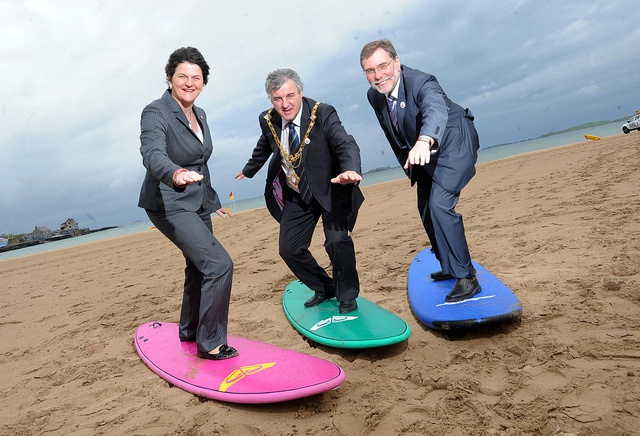Describe the objects in this image and their specific colors. I can see people in white, black, gray, and navy tones, people in white, black, gray, tan, and darkgray tones, people in white, gray, black, and lightpink tones, surfboard in white, violet, and lightpink tones, and surfboard in white, lightblue, black, gray, and blue tones in this image. 